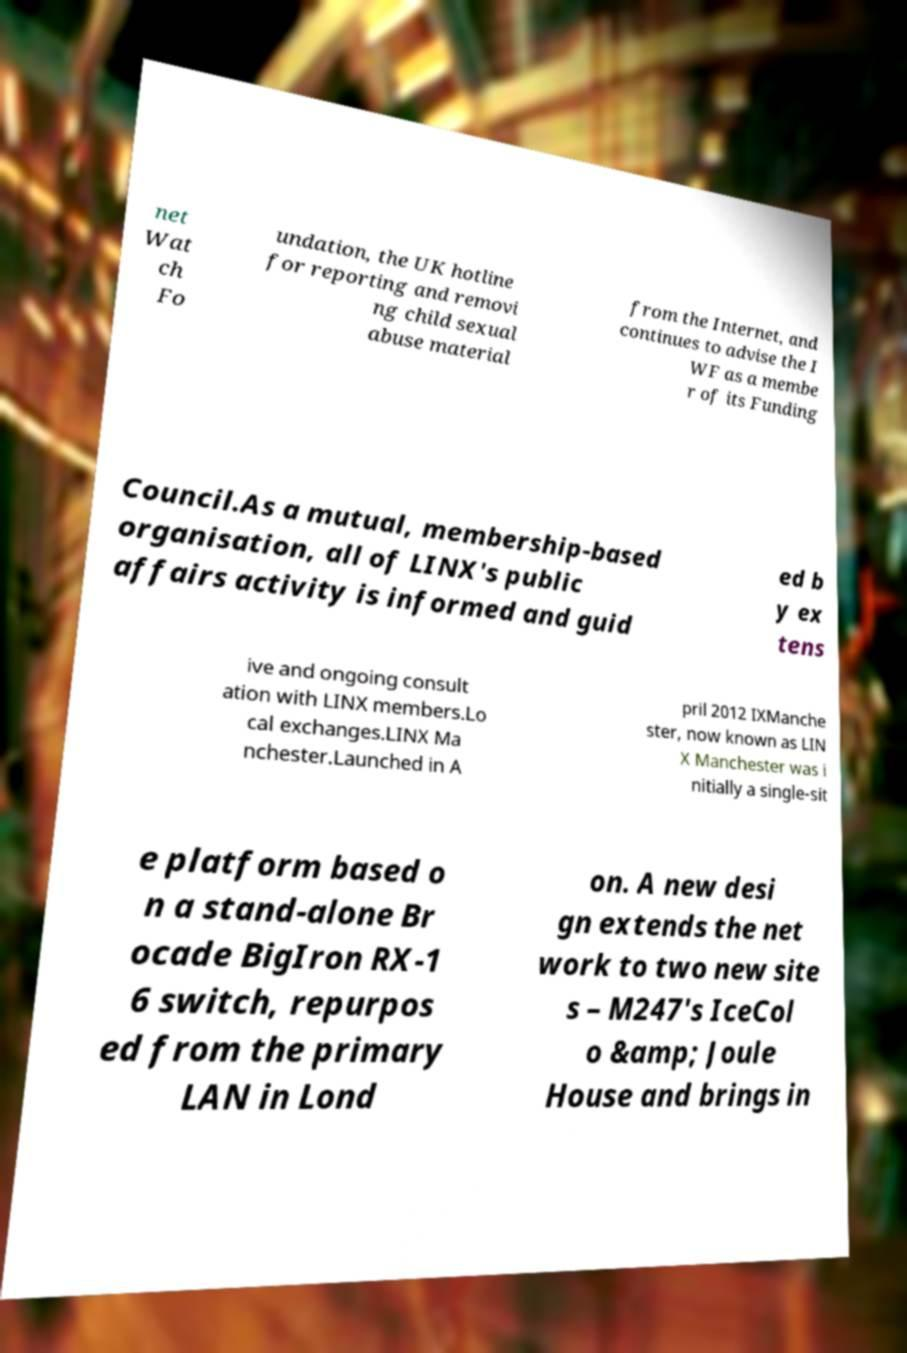I need the written content from this picture converted into text. Can you do that? net Wat ch Fo undation, the UK hotline for reporting and removi ng child sexual abuse material from the Internet, and continues to advise the I WF as a membe r of its Funding Council.As a mutual, membership-based organisation, all of LINX's public affairs activity is informed and guid ed b y ex tens ive and ongoing consult ation with LINX members.Lo cal exchanges.LINX Ma nchester.Launched in A pril 2012 IXManche ster, now known as LIN X Manchester was i nitially a single-sit e platform based o n a stand-alone Br ocade BigIron RX-1 6 switch, repurpos ed from the primary LAN in Lond on. A new desi gn extends the net work to two new site s – M247's IceCol o &amp; Joule House and brings in 